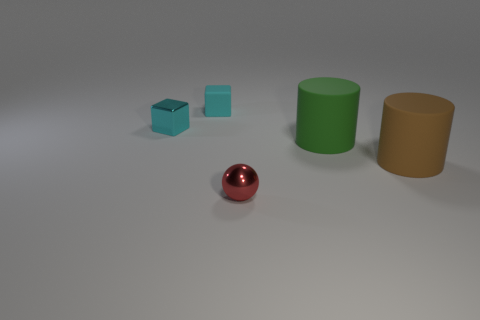Can you describe the lighting in this scene? The lighting appears to be diffused, casting soft shadows to the bottom and right of the objects, suggesting a light source coming from the top left side of the scene. What can you infer from the shadows about the position of the light source? The shadows extend toward the bottom right, which indicates that the light source is positioned above and to the left of the objects, somewhat in front of them. 